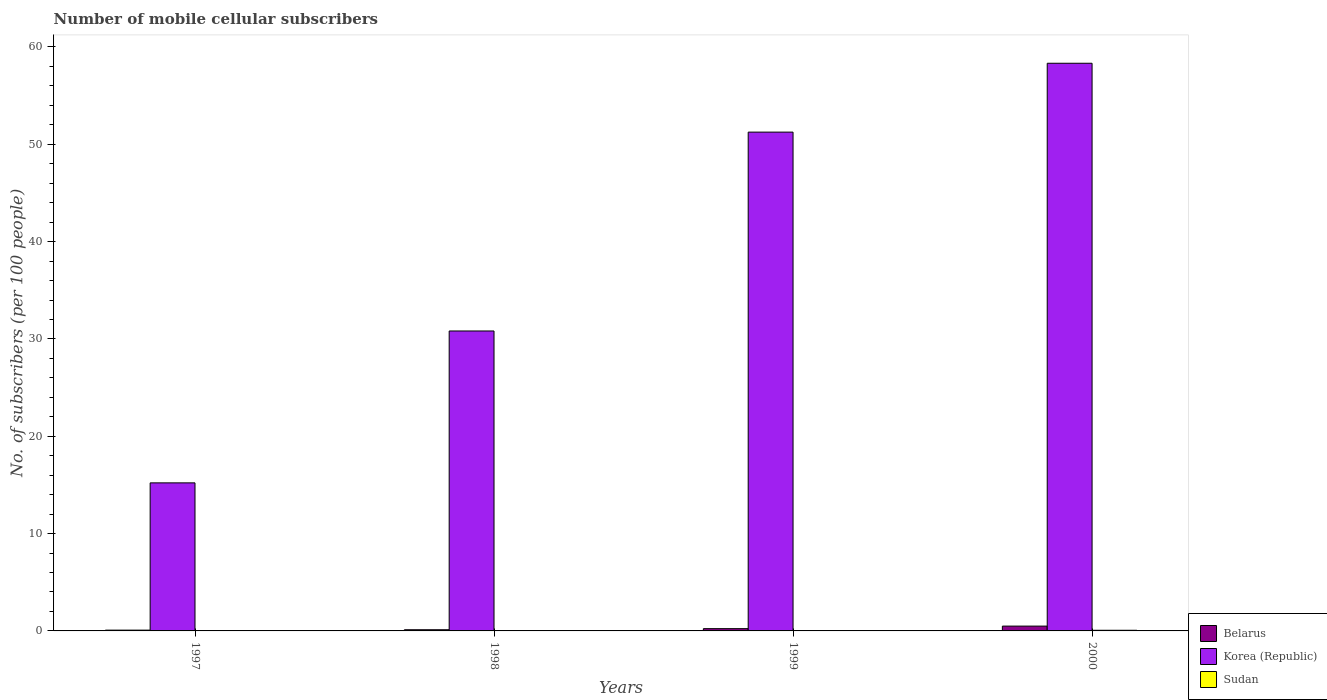How many groups of bars are there?
Keep it short and to the point. 4. Are the number of bars per tick equal to the number of legend labels?
Give a very brief answer. Yes. What is the label of the 3rd group of bars from the left?
Your answer should be very brief. 1999. In how many cases, is the number of bars for a given year not equal to the number of legend labels?
Ensure brevity in your answer.  0. What is the number of mobile cellular subscribers in Sudan in 2000?
Ensure brevity in your answer.  0.07. Across all years, what is the maximum number of mobile cellular subscribers in Belarus?
Offer a terse response. 0.49. Across all years, what is the minimum number of mobile cellular subscribers in Belarus?
Make the answer very short. 0.08. In which year was the number of mobile cellular subscribers in Korea (Republic) maximum?
Provide a short and direct response. 2000. In which year was the number of mobile cellular subscribers in Belarus minimum?
Offer a very short reply. 1997. What is the total number of mobile cellular subscribers in Korea (Republic) in the graph?
Your response must be concise. 155.6. What is the difference between the number of mobile cellular subscribers in Belarus in 1997 and that in 1998?
Offer a terse response. -0.04. What is the difference between the number of mobile cellular subscribers in Belarus in 1998 and the number of mobile cellular subscribers in Korea (Republic) in 1997?
Give a very brief answer. -15.09. What is the average number of mobile cellular subscribers in Belarus per year?
Give a very brief answer. 0.23. In the year 1998, what is the difference between the number of mobile cellular subscribers in Belarus and number of mobile cellular subscribers in Korea (Republic)?
Provide a succinct answer. -30.7. What is the ratio of the number of mobile cellular subscribers in Sudan in 1999 to that in 2000?
Give a very brief answer. 0.58. Is the number of mobile cellular subscribers in Belarus in 1998 less than that in 1999?
Provide a succinct answer. Yes. Is the difference between the number of mobile cellular subscribers in Belarus in 1997 and 2000 greater than the difference between the number of mobile cellular subscribers in Korea (Republic) in 1997 and 2000?
Offer a terse response. Yes. What is the difference between the highest and the second highest number of mobile cellular subscribers in Belarus?
Offer a terse response. 0.26. What is the difference between the highest and the lowest number of mobile cellular subscribers in Belarus?
Ensure brevity in your answer.  0.41. In how many years, is the number of mobile cellular subscribers in Belarus greater than the average number of mobile cellular subscribers in Belarus taken over all years?
Provide a short and direct response. 2. Is the sum of the number of mobile cellular subscribers in Belarus in 1997 and 1999 greater than the maximum number of mobile cellular subscribers in Sudan across all years?
Provide a short and direct response. Yes. What does the 3rd bar from the left in 2000 represents?
Offer a very short reply. Sudan. What does the 1st bar from the right in 2000 represents?
Offer a very short reply. Sudan. Is it the case that in every year, the sum of the number of mobile cellular subscribers in Korea (Republic) and number of mobile cellular subscribers in Sudan is greater than the number of mobile cellular subscribers in Belarus?
Offer a very short reply. Yes. Are the values on the major ticks of Y-axis written in scientific E-notation?
Keep it short and to the point. No. Does the graph contain any zero values?
Provide a short and direct response. No. What is the title of the graph?
Keep it short and to the point. Number of mobile cellular subscribers. Does "Latvia" appear as one of the legend labels in the graph?
Provide a succinct answer. No. What is the label or title of the Y-axis?
Your response must be concise. No. of subscribers (per 100 people). What is the No. of subscribers (per 100 people) in Belarus in 1997?
Your answer should be compact. 0.08. What is the No. of subscribers (per 100 people) in Korea (Republic) in 1997?
Provide a short and direct response. 15.21. What is the No. of subscribers (per 100 people) of Sudan in 1997?
Give a very brief answer. 0.01. What is the No. of subscribers (per 100 people) of Belarus in 1998?
Your answer should be compact. 0.12. What is the No. of subscribers (per 100 people) in Korea (Republic) in 1998?
Make the answer very short. 30.82. What is the No. of subscribers (per 100 people) in Sudan in 1998?
Your answer should be compact. 0.03. What is the No. of subscribers (per 100 people) in Belarus in 1999?
Keep it short and to the point. 0.23. What is the No. of subscribers (per 100 people) of Korea (Republic) in 1999?
Your answer should be very brief. 51.25. What is the No. of subscribers (per 100 people) in Sudan in 1999?
Keep it short and to the point. 0.04. What is the No. of subscribers (per 100 people) in Belarus in 2000?
Provide a succinct answer. 0.49. What is the No. of subscribers (per 100 people) in Korea (Republic) in 2000?
Your response must be concise. 58.33. What is the No. of subscribers (per 100 people) in Sudan in 2000?
Your answer should be compact. 0.07. Across all years, what is the maximum No. of subscribers (per 100 people) in Belarus?
Keep it short and to the point. 0.49. Across all years, what is the maximum No. of subscribers (per 100 people) of Korea (Republic)?
Offer a very short reply. 58.33. Across all years, what is the maximum No. of subscribers (per 100 people) in Sudan?
Offer a very short reply. 0.07. Across all years, what is the minimum No. of subscribers (per 100 people) in Belarus?
Ensure brevity in your answer.  0.08. Across all years, what is the minimum No. of subscribers (per 100 people) in Korea (Republic)?
Your response must be concise. 15.21. Across all years, what is the minimum No. of subscribers (per 100 people) in Sudan?
Offer a terse response. 0.01. What is the total No. of subscribers (per 100 people) of Belarus in the graph?
Ensure brevity in your answer.  0.93. What is the total No. of subscribers (per 100 people) in Korea (Republic) in the graph?
Ensure brevity in your answer.  155.6. What is the total No. of subscribers (per 100 people) of Sudan in the graph?
Provide a short and direct response. 0.14. What is the difference between the No. of subscribers (per 100 people) in Belarus in 1997 and that in 1998?
Your answer should be compact. -0.04. What is the difference between the No. of subscribers (per 100 people) in Korea (Republic) in 1997 and that in 1998?
Provide a succinct answer. -15.61. What is the difference between the No. of subscribers (per 100 people) of Sudan in 1997 and that in 1998?
Offer a terse response. -0.01. What is the difference between the No. of subscribers (per 100 people) in Belarus in 1997 and that in 1999?
Offer a terse response. -0.15. What is the difference between the No. of subscribers (per 100 people) of Korea (Republic) in 1997 and that in 1999?
Provide a succinct answer. -36.04. What is the difference between the No. of subscribers (per 100 people) of Sudan in 1997 and that in 1999?
Keep it short and to the point. -0.03. What is the difference between the No. of subscribers (per 100 people) in Belarus in 1997 and that in 2000?
Ensure brevity in your answer.  -0.41. What is the difference between the No. of subscribers (per 100 people) in Korea (Republic) in 1997 and that in 2000?
Your answer should be compact. -43.11. What is the difference between the No. of subscribers (per 100 people) of Sudan in 1997 and that in 2000?
Provide a short and direct response. -0.06. What is the difference between the No. of subscribers (per 100 people) in Belarus in 1998 and that in 1999?
Make the answer very short. -0.11. What is the difference between the No. of subscribers (per 100 people) of Korea (Republic) in 1998 and that in 1999?
Ensure brevity in your answer.  -20.43. What is the difference between the No. of subscribers (per 100 people) in Sudan in 1998 and that in 1999?
Keep it short and to the point. -0.01. What is the difference between the No. of subscribers (per 100 people) in Belarus in 1998 and that in 2000?
Your response must be concise. -0.37. What is the difference between the No. of subscribers (per 100 people) in Korea (Republic) in 1998 and that in 2000?
Provide a succinct answer. -27.51. What is the difference between the No. of subscribers (per 100 people) in Sudan in 1998 and that in 2000?
Offer a very short reply. -0.04. What is the difference between the No. of subscribers (per 100 people) of Belarus in 1999 and that in 2000?
Offer a very short reply. -0.26. What is the difference between the No. of subscribers (per 100 people) in Korea (Republic) in 1999 and that in 2000?
Offer a very short reply. -7.08. What is the difference between the No. of subscribers (per 100 people) in Sudan in 1999 and that in 2000?
Give a very brief answer. -0.03. What is the difference between the No. of subscribers (per 100 people) in Belarus in 1997 and the No. of subscribers (per 100 people) in Korea (Republic) in 1998?
Your answer should be compact. -30.74. What is the difference between the No. of subscribers (per 100 people) in Belarus in 1997 and the No. of subscribers (per 100 people) in Sudan in 1998?
Make the answer very short. 0.05. What is the difference between the No. of subscribers (per 100 people) in Korea (Republic) in 1997 and the No. of subscribers (per 100 people) in Sudan in 1998?
Provide a succinct answer. 15.19. What is the difference between the No. of subscribers (per 100 people) in Belarus in 1997 and the No. of subscribers (per 100 people) in Korea (Republic) in 1999?
Your response must be concise. -51.17. What is the difference between the No. of subscribers (per 100 people) of Belarus in 1997 and the No. of subscribers (per 100 people) of Sudan in 1999?
Your response must be concise. 0.04. What is the difference between the No. of subscribers (per 100 people) of Korea (Republic) in 1997 and the No. of subscribers (per 100 people) of Sudan in 1999?
Provide a short and direct response. 15.17. What is the difference between the No. of subscribers (per 100 people) in Belarus in 1997 and the No. of subscribers (per 100 people) in Korea (Republic) in 2000?
Offer a very short reply. -58.24. What is the difference between the No. of subscribers (per 100 people) of Belarus in 1997 and the No. of subscribers (per 100 people) of Sudan in 2000?
Offer a very short reply. 0.01. What is the difference between the No. of subscribers (per 100 people) in Korea (Republic) in 1997 and the No. of subscribers (per 100 people) in Sudan in 2000?
Keep it short and to the point. 15.14. What is the difference between the No. of subscribers (per 100 people) of Belarus in 1998 and the No. of subscribers (per 100 people) of Korea (Republic) in 1999?
Make the answer very short. -51.13. What is the difference between the No. of subscribers (per 100 people) of Belarus in 1998 and the No. of subscribers (per 100 people) of Sudan in 1999?
Your answer should be compact. 0.08. What is the difference between the No. of subscribers (per 100 people) of Korea (Republic) in 1998 and the No. of subscribers (per 100 people) of Sudan in 1999?
Your answer should be compact. 30.78. What is the difference between the No. of subscribers (per 100 people) of Belarus in 1998 and the No. of subscribers (per 100 people) of Korea (Republic) in 2000?
Provide a succinct answer. -58.2. What is the difference between the No. of subscribers (per 100 people) of Belarus in 1998 and the No. of subscribers (per 100 people) of Sudan in 2000?
Ensure brevity in your answer.  0.05. What is the difference between the No. of subscribers (per 100 people) of Korea (Republic) in 1998 and the No. of subscribers (per 100 people) of Sudan in 2000?
Offer a terse response. 30.75. What is the difference between the No. of subscribers (per 100 people) in Belarus in 1999 and the No. of subscribers (per 100 people) in Korea (Republic) in 2000?
Your response must be concise. -58.09. What is the difference between the No. of subscribers (per 100 people) in Belarus in 1999 and the No. of subscribers (per 100 people) in Sudan in 2000?
Your answer should be very brief. 0.17. What is the difference between the No. of subscribers (per 100 people) of Korea (Republic) in 1999 and the No. of subscribers (per 100 people) of Sudan in 2000?
Keep it short and to the point. 51.18. What is the average No. of subscribers (per 100 people) in Belarus per year?
Ensure brevity in your answer.  0.23. What is the average No. of subscribers (per 100 people) of Korea (Republic) per year?
Keep it short and to the point. 38.9. What is the average No. of subscribers (per 100 people) in Sudan per year?
Your answer should be compact. 0.04. In the year 1997, what is the difference between the No. of subscribers (per 100 people) of Belarus and No. of subscribers (per 100 people) of Korea (Republic)?
Give a very brief answer. -15.13. In the year 1997, what is the difference between the No. of subscribers (per 100 people) of Belarus and No. of subscribers (per 100 people) of Sudan?
Offer a terse response. 0.07. In the year 1997, what is the difference between the No. of subscribers (per 100 people) in Korea (Republic) and No. of subscribers (per 100 people) in Sudan?
Keep it short and to the point. 15.2. In the year 1998, what is the difference between the No. of subscribers (per 100 people) of Belarus and No. of subscribers (per 100 people) of Korea (Republic)?
Provide a short and direct response. -30.7. In the year 1998, what is the difference between the No. of subscribers (per 100 people) in Belarus and No. of subscribers (per 100 people) in Sudan?
Provide a succinct answer. 0.09. In the year 1998, what is the difference between the No. of subscribers (per 100 people) in Korea (Republic) and No. of subscribers (per 100 people) in Sudan?
Give a very brief answer. 30.79. In the year 1999, what is the difference between the No. of subscribers (per 100 people) of Belarus and No. of subscribers (per 100 people) of Korea (Republic)?
Keep it short and to the point. -51.02. In the year 1999, what is the difference between the No. of subscribers (per 100 people) in Belarus and No. of subscribers (per 100 people) in Sudan?
Make the answer very short. 0.19. In the year 1999, what is the difference between the No. of subscribers (per 100 people) in Korea (Republic) and No. of subscribers (per 100 people) in Sudan?
Keep it short and to the point. 51.21. In the year 2000, what is the difference between the No. of subscribers (per 100 people) in Belarus and No. of subscribers (per 100 people) in Korea (Republic)?
Offer a terse response. -57.83. In the year 2000, what is the difference between the No. of subscribers (per 100 people) in Belarus and No. of subscribers (per 100 people) in Sudan?
Offer a very short reply. 0.43. In the year 2000, what is the difference between the No. of subscribers (per 100 people) of Korea (Republic) and No. of subscribers (per 100 people) of Sudan?
Give a very brief answer. 58.26. What is the ratio of the No. of subscribers (per 100 people) of Belarus in 1997 to that in 1998?
Ensure brevity in your answer.  0.67. What is the ratio of the No. of subscribers (per 100 people) in Korea (Republic) in 1997 to that in 1998?
Your answer should be very brief. 0.49. What is the ratio of the No. of subscribers (per 100 people) of Sudan in 1997 to that in 1998?
Give a very brief answer. 0.45. What is the ratio of the No. of subscribers (per 100 people) of Belarus in 1997 to that in 1999?
Keep it short and to the point. 0.35. What is the ratio of the No. of subscribers (per 100 people) in Korea (Republic) in 1997 to that in 1999?
Your answer should be very brief. 0.3. What is the ratio of the No. of subscribers (per 100 people) of Sudan in 1997 to that in 1999?
Your answer should be very brief. 0.31. What is the ratio of the No. of subscribers (per 100 people) in Belarus in 1997 to that in 2000?
Your answer should be compact. 0.16. What is the ratio of the No. of subscribers (per 100 people) of Korea (Republic) in 1997 to that in 2000?
Offer a terse response. 0.26. What is the ratio of the No. of subscribers (per 100 people) in Sudan in 1997 to that in 2000?
Give a very brief answer. 0.18. What is the ratio of the No. of subscribers (per 100 people) in Belarus in 1998 to that in 1999?
Ensure brevity in your answer.  0.52. What is the ratio of the No. of subscribers (per 100 people) of Korea (Republic) in 1998 to that in 1999?
Your answer should be compact. 0.6. What is the ratio of the No. of subscribers (per 100 people) of Sudan in 1998 to that in 1999?
Ensure brevity in your answer.  0.68. What is the ratio of the No. of subscribers (per 100 people) of Belarus in 1998 to that in 2000?
Ensure brevity in your answer.  0.24. What is the ratio of the No. of subscribers (per 100 people) of Korea (Republic) in 1998 to that in 2000?
Provide a succinct answer. 0.53. What is the ratio of the No. of subscribers (per 100 people) in Sudan in 1998 to that in 2000?
Ensure brevity in your answer.  0.39. What is the ratio of the No. of subscribers (per 100 people) in Belarus in 1999 to that in 2000?
Ensure brevity in your answer.  0.47. What is the ratio of the No. of subscribers (per 100 people) of Korea (Republic) in 1999 to that in 2000?
Make the answer very short. 0.88. What is the ratio of the No. of subscribers (per 100 people) in Sudan in 1999 to that in 2000?
Offer a terse response. 0.58. What is the difference between the highest and the second highest No. of subscribers (per 100 people) of Belarus?
Your response must be concise. 0.26. What is the difference between the highest and the second highest No. of subscribers (per 100 people) in Korea (Republic)?
Offer a very short reply. 7.08. What is the difference between the highest and the second highest No. of subscribers (per 100 people) of Sudan?
Your response must be concise. 0.03. What is the difference between the highest and the lowest No. of subscribers (per 100 people) of Belarus?
Provide a succinct answer. 0.41. What is the difference between the highest and the lowest No. of subscribers (per 100 people) of Korea (Republic)?
Your response must be concise. 43.11. What is the difference between the highest and the lowest No. of subscribers (per 100 people) in Sudan?
Your response must be concise. 0.06. 